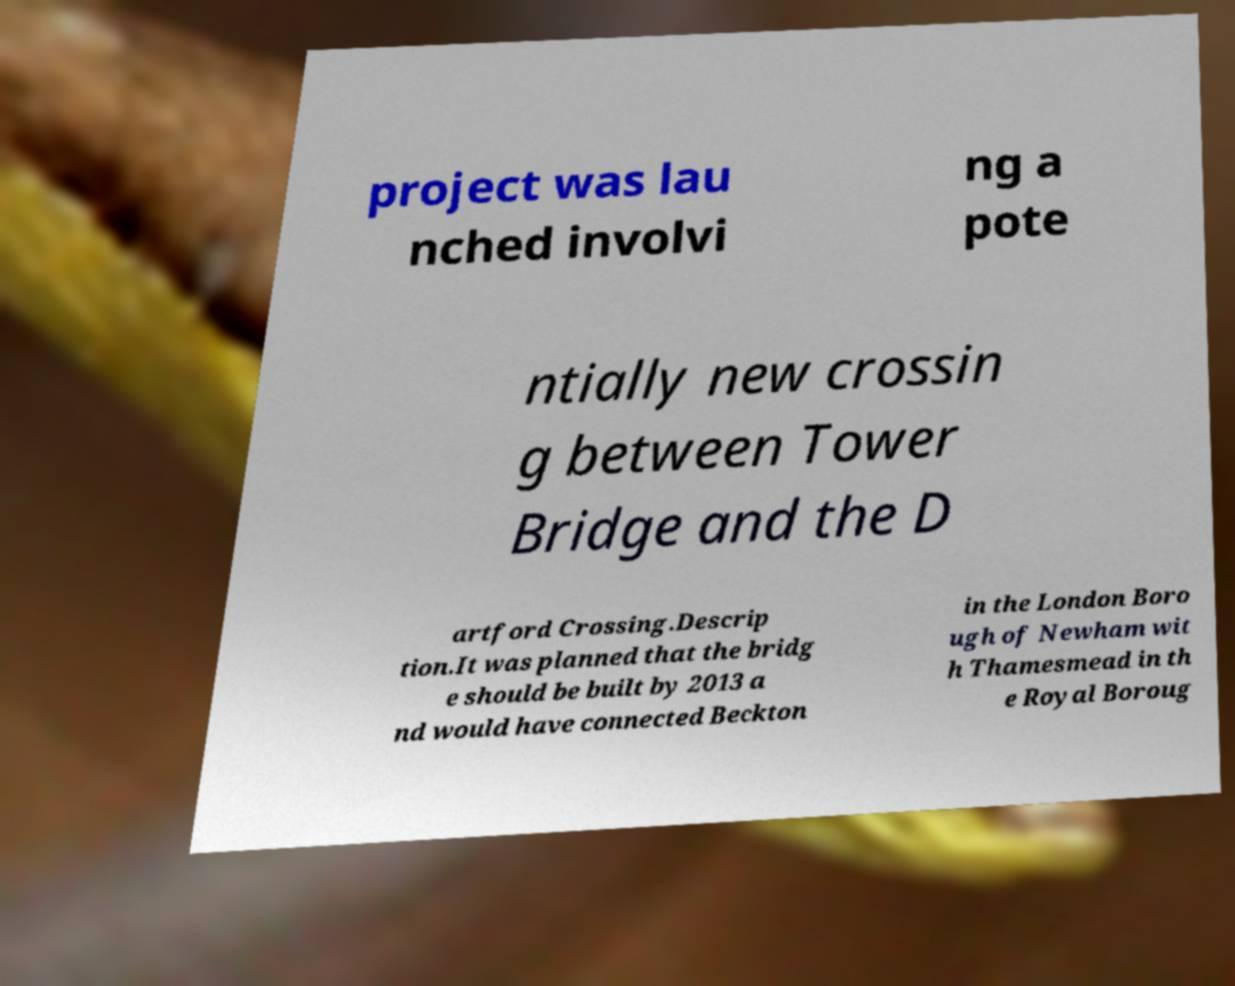Can you accurately transcribe the text from the provided image for me? project was lau nched involvi ng a pote ntially new crossin g between Tower Bridge and the D artford Crossing.Descrip tion.It was planned that the bridg e should be built by 2013 a nd would have connected Beckton in the London Boro ugh of Newham wit h Thamesmead in th e Royal Boroug 